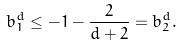Convert formula to latex. <formula><loc_0><loc_0><loc_500><loc_500>b ^ { d } _ { 1 } \leq - 1 - \frac { 2 } { d + 2 } = b ^ { d } _ { 2 } .</formula> 